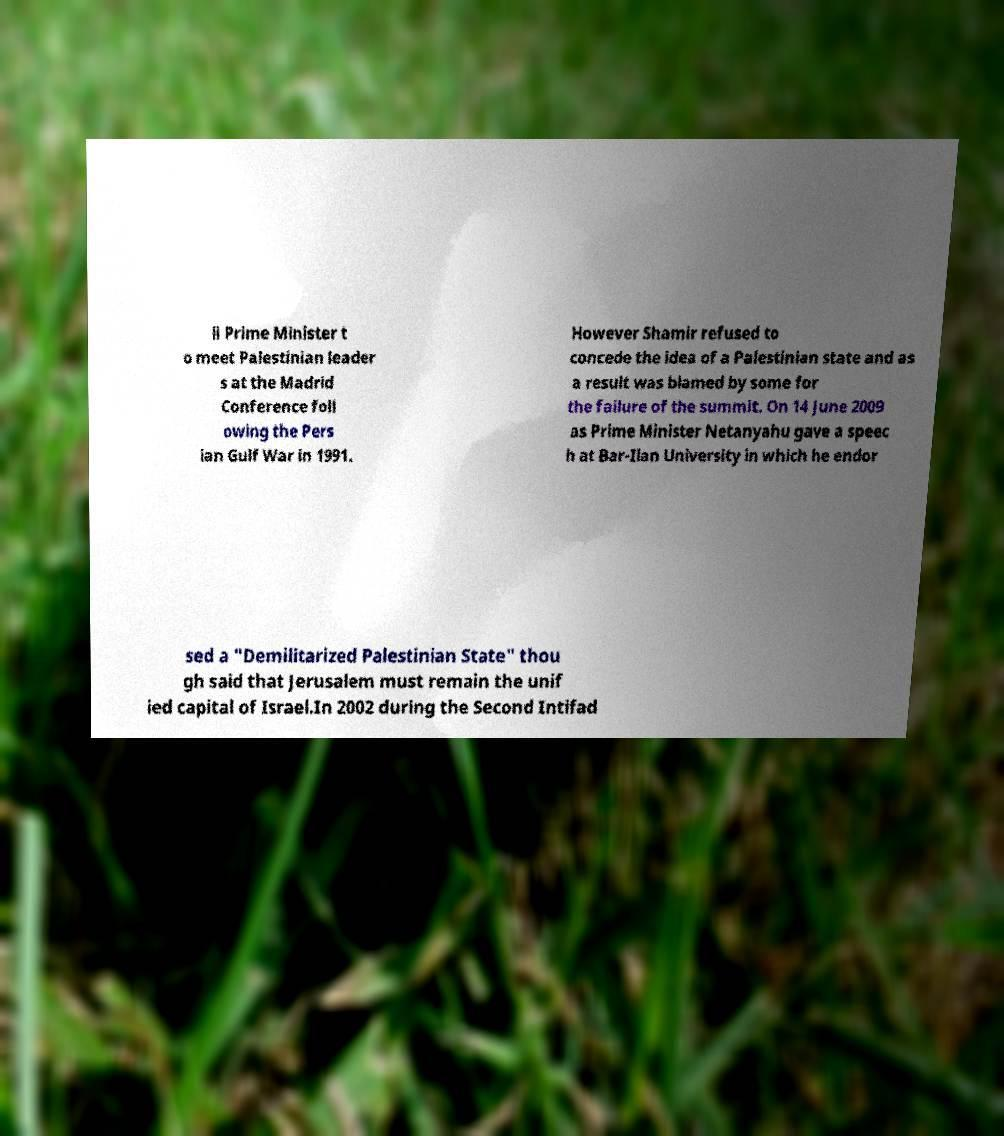For documentation purposes, I need the text within this image transcribed. Could you provide that? li Prime Minister t o meet Palestinian leader s at the Madrid Conference foll owing the Pers ian Gulf War in 1991. However Shamir refused to concede the idea of a Palestinian state and as a result was blamed by some for the failure of the summit. On 14 June 2009 as Prime Minister Netanyahu gave a speec h at Bar-Ilan University in which he endor sed a "Demilitarized Palestinian State" thou gh said that Jerusalem must remain the unif ied capital of Israel.In 2002 during the Second Intifad 